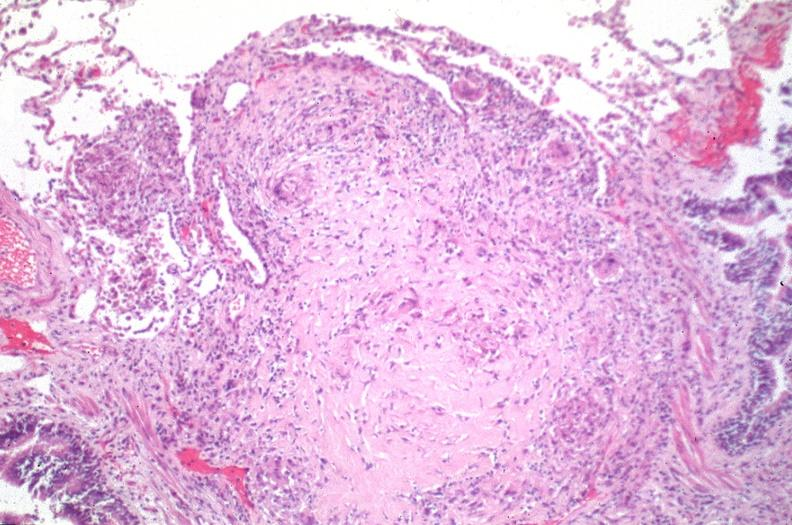what is present?
Answer the question using a single word or phrase. Respiratory 